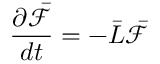Convert formula to latex. <formula><loc_0><loc_0><loc_500><loc_500>\frac { \partial \bar { \mathcal { F } } } { d t } = - \bar { L } \bar { \mathcal { F } }</formula> 